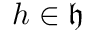<formula> <loc_0><loc_0><loc_500><loc_500>h \in { \mathfrak { h } }</formula> 